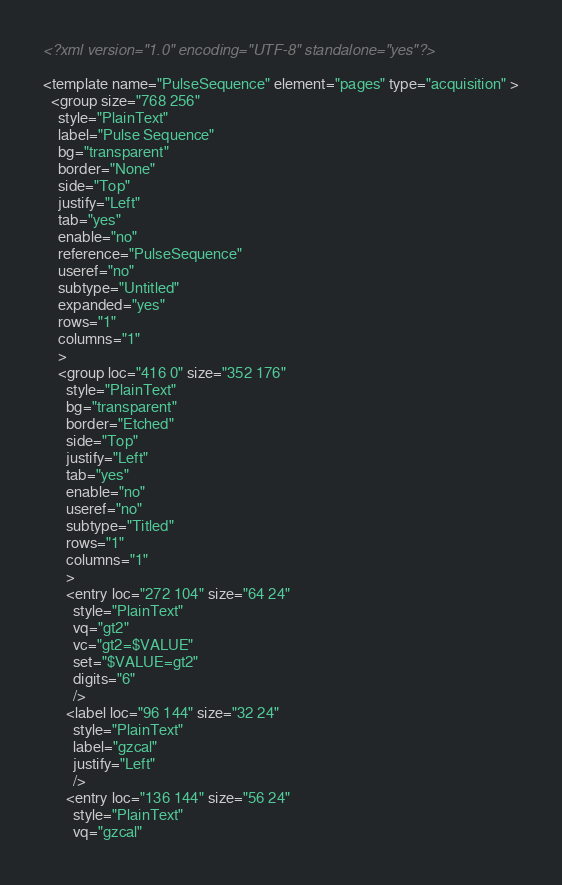Convert code to text. <code><loc_0><loc_0><loc_500><loc_500><_XML_><?xml version="1.0" encoding="UTF-8" standalone="yes"?>

<template name="PulseSequence" element="pages" type="acquisition" >
  <group size="768 256"
    style="PlainText"
    label="Pulse Sequence"
    bg="transparent"
    border="None"
    side="Top"
    justify="Left"
    tab="yes"
    enable="no"
    reference="PulseSequence"
    useref="no"
    subtype="Untitled"
    expanded="yes"
    rows="1"
    columns="1"
    >
    <group loc="416 0" size="352 176"
      style="PlainText"
      bg="transparent"
      border="Etched"
      side="Top"
      justify="Left"
      tab="yes"
      enable="no"
      useref="no"
      subtype="Titled"
      rows="1"
      columns="1"
      >
      <entry loc="272 104" size="64 24"
        style="PlainText"
        vq="gt2"
        vc="gt2=$VALUE"
        set="$VALUE=gt2"
        digits="6"
        />
      <label loc="96 144" size="32 24"
        style="PlainText"
        label="gzcal"
        justify="Left"
        />
      <entry loc="136 144" size="56 24"
        style="PlainText"
        vq="gzcal"</code> 